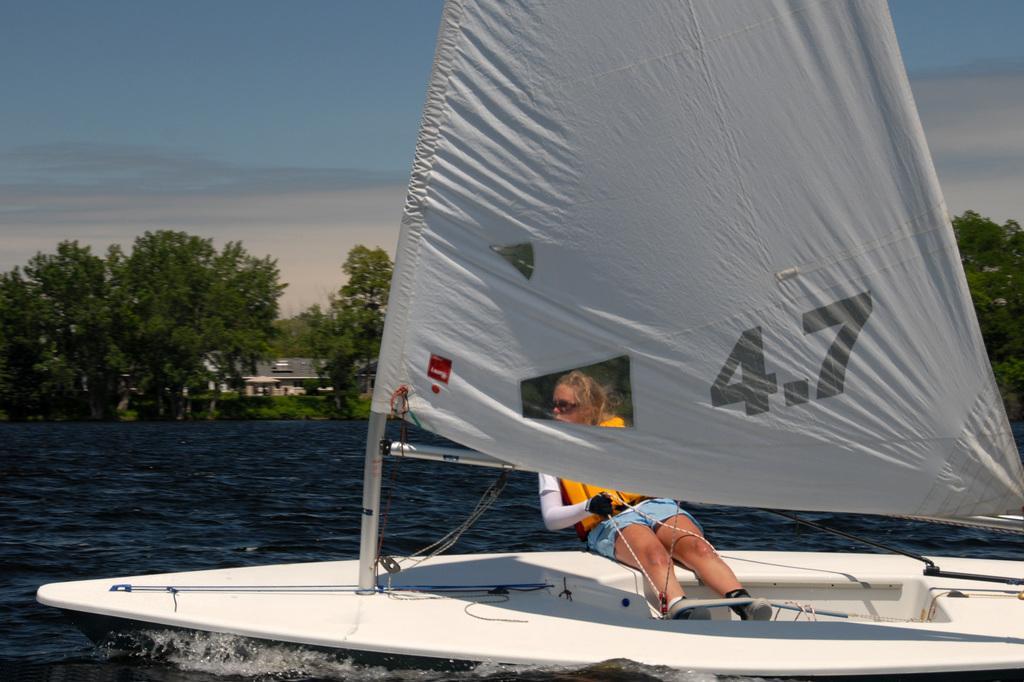Can you describe this image briefly? In this image I can see water and on it I can see a white colour boat. I can also see one woman is sitting on the boat and I can see she is wearing shades, gloves, shorts, shoes and life jacket. In the background I can see number of trees, a house, clouds and the sky. In the front I can see something is written on the cloth. 